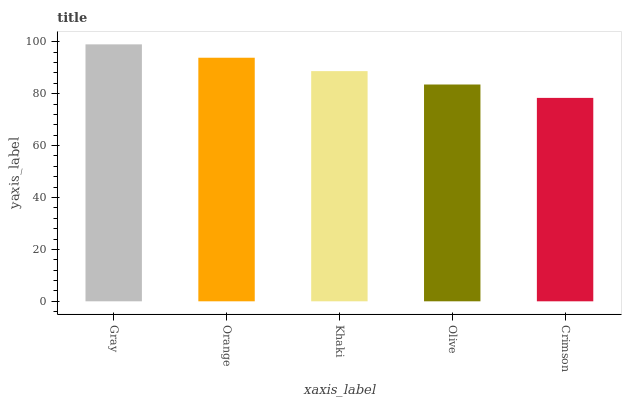Is Crimson the minimum?
Answer yes or no. Yes. Is Gray the maximum?
Answer yes or no. Yes. Is Orange the minimum?
Answer yes or no. No. Is Orange the maximum?
Answer yes or no. No. Is Gray greater than Orange?
Answer yes or no. Yes. Is Orange less than Gray?
Answer yes or no. Yes. Is Orange greater than Gray?
Answer yes or no. No. Is Gray less than Orange?
Answer yes or no. No. Is Khaki the high median?
Answer yes or no. Yes. Is Khaki the low median?
Answer yes or no. Yes. Is Gray the high median?
Answer yes or no. No. Is Crimson the low median?
Answer yes or no. No. 